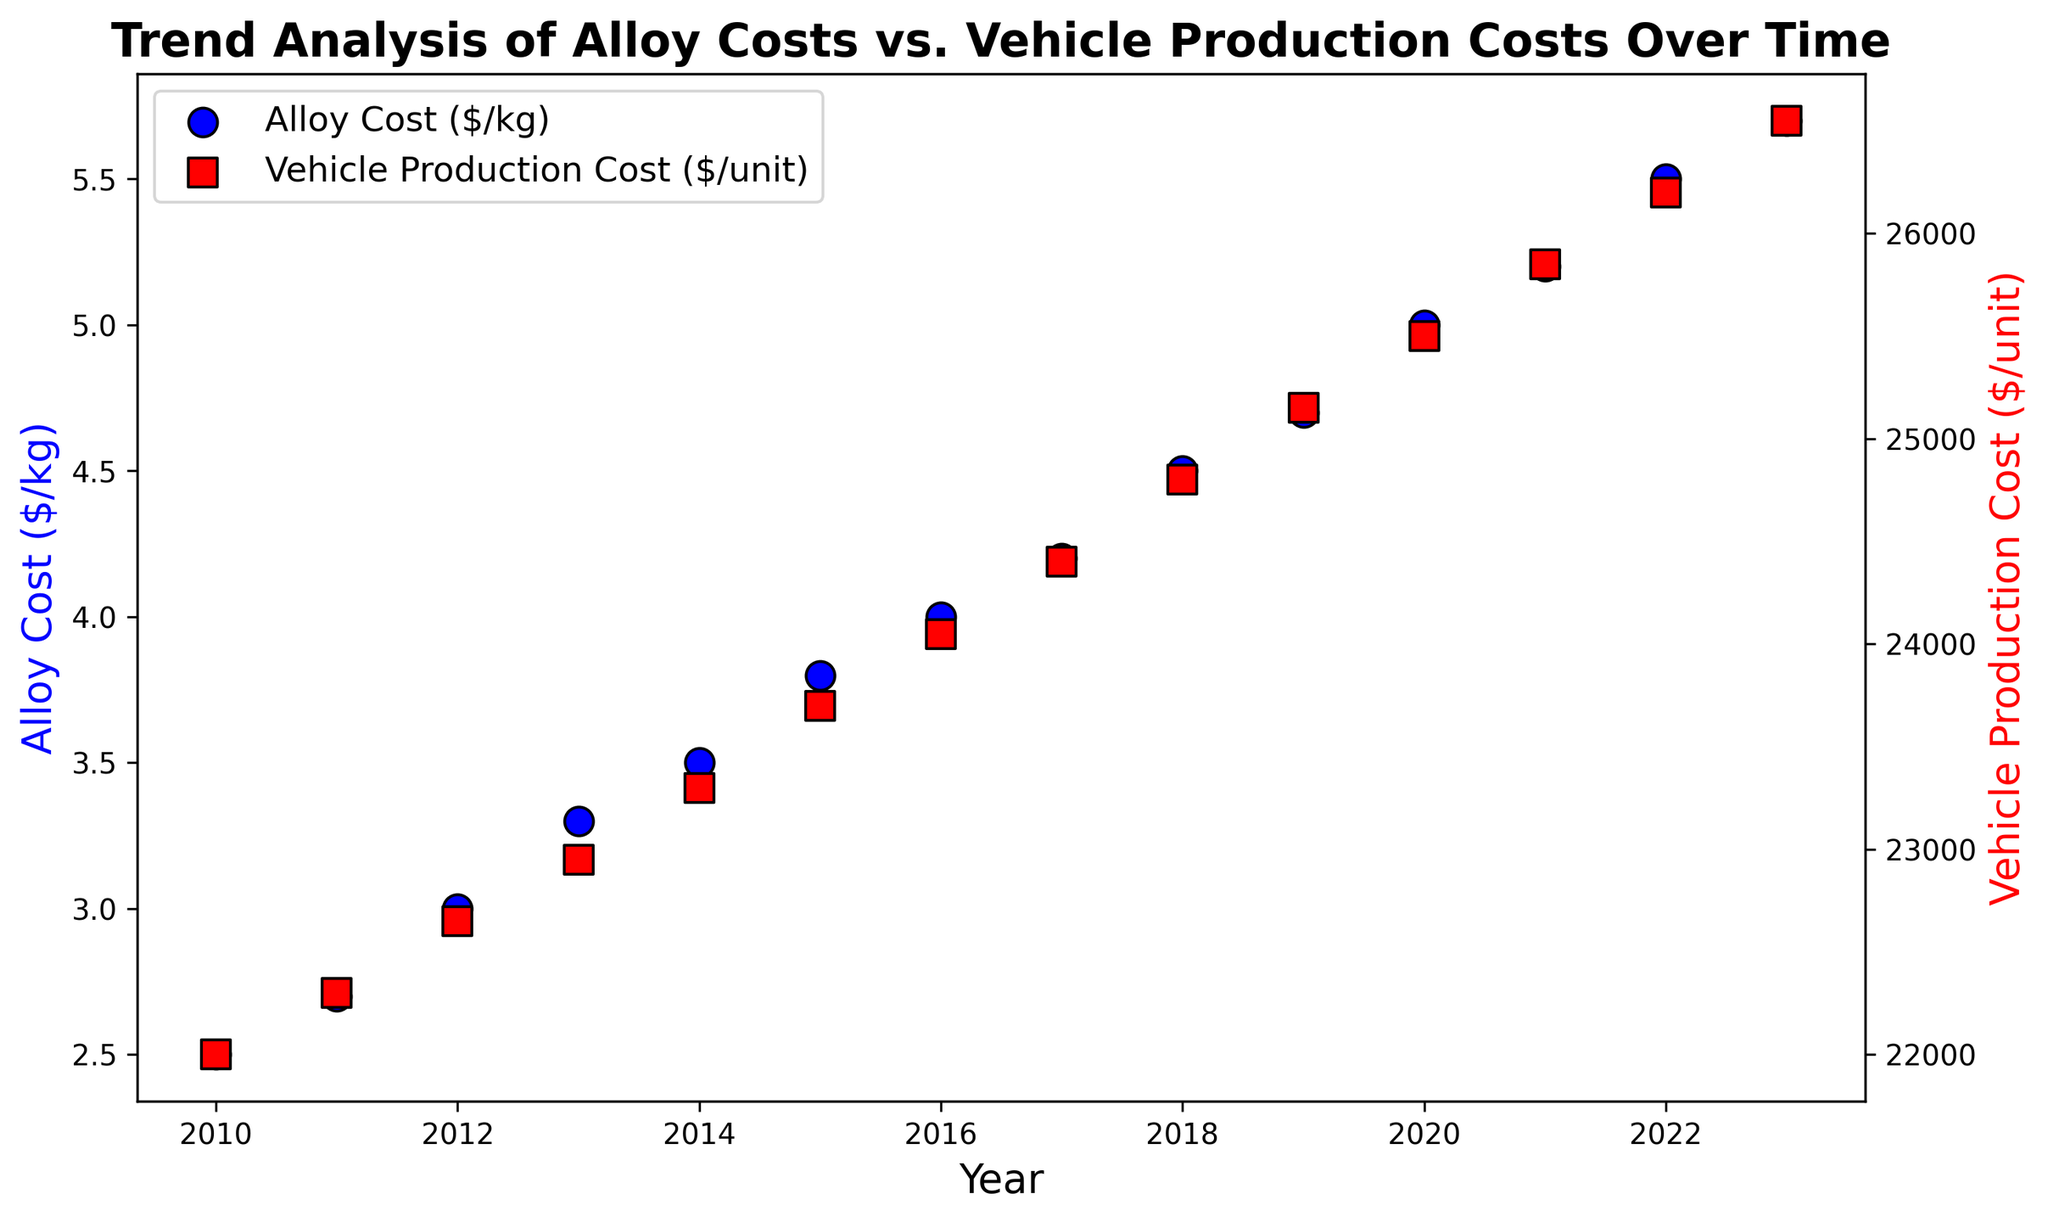How do the trends for alloy costs and vehicle production costs compare over time? Both alloy costs and vehicle production costs show an increasing trend from 2010 to 2023. The alloy costs increase from $2.5/kg to $5.7/kg, while vehicle production costs increase from $22,000/unit to $26,550/unit.
Answer: Both trends increase What is the difference in vehicle production cost between 2020 and 2023? The vehicle production cost in 2020 is $25,500, and in 2023 it is $26,550. The difference is calculated as $26,550 - $25,500.
Answer: $1,050 During which year did alloy costs rise the most sharply? By examining the slope of the points in the blue scatter plot, we see that the year-to-year increase in costs is highest between 2014 ($3.5/kg) and 2015 ($3.8/kg).
Answer: 2015 Is there a year where the increase in alloy cost did not significantly impact the vehicle production cost? The increase from 2018 ($4.5/kg) to 2019 ($4.7/kg) doesn't seem to have as large an impact on production costs, which rise modestly from $24,800 to $25,150.
Answer: 2019 Which year has the highest vehicle production cost, and what is the alloy cost in that year? The highest vehicle production cost is in 2023 at $26,550. That year, the alloy cost is $5.7/kg.
Answer: 2023, $5.7/kg What is the average annual increase in alloy costs from 2010 to 2023? To find the average annual increase, subtract the alloy cost in 2010 from that in 2023, then divide by the number of years. ($5.7 - $2.5)/(2023-2010) = $3.2/13.
Answer: $0.246 per year Compare the relative steepness of the trends in alloy costs and vehicle production costs. Which one is steeper? The line representing alloy costs shows a more consistent and sharper increase compared to the vehicle production costs, indicating a steeper trend.
Answer: Alloy costs At what rate do vehicle production costs increase relative to alloy costs on average? To find the rate, consider the total increase in vehicle production costs ($26,550 - $22,000 = $4,550) over the total increase in alloy costs ($5.7 - $2.5 = $3.2). The average rate is $4,550/$3.2 per kg.
Answer: $1,421.875 per kg What can be inferred if both trends were to continue in a similar manner for the next 5 years? If both trends continue, alloy costs and vehicle production costs will both significantly increase. Alloy costs could reach approximately $7.0/kg, and vehicle production costs could exceed $30,000/unit assuming similar growth rates.
Answer: Significant increases in both 